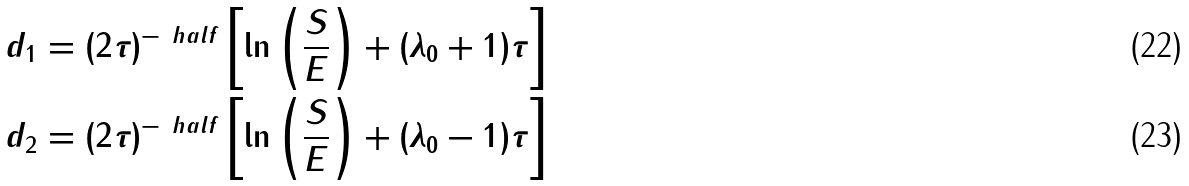<formula> <loc_0><loc_0><loc_500><loc_500>d _ { 1 } & = ( 2 \tau ) ^ { - \ h a l f } \left [ \ln \left ( \frac { S } { E } \right ) + ( \lambda _ { 0 } + 1 ) \tau \right ] \\ d _ { 2 } & = ( 2 \tau ) ^ { - \ h a l f } \left [ \ln \left ( \frac { S } { E } \right ) + ( \lambda _ { 0 } - 1 ) \tau \right ]</formula> 